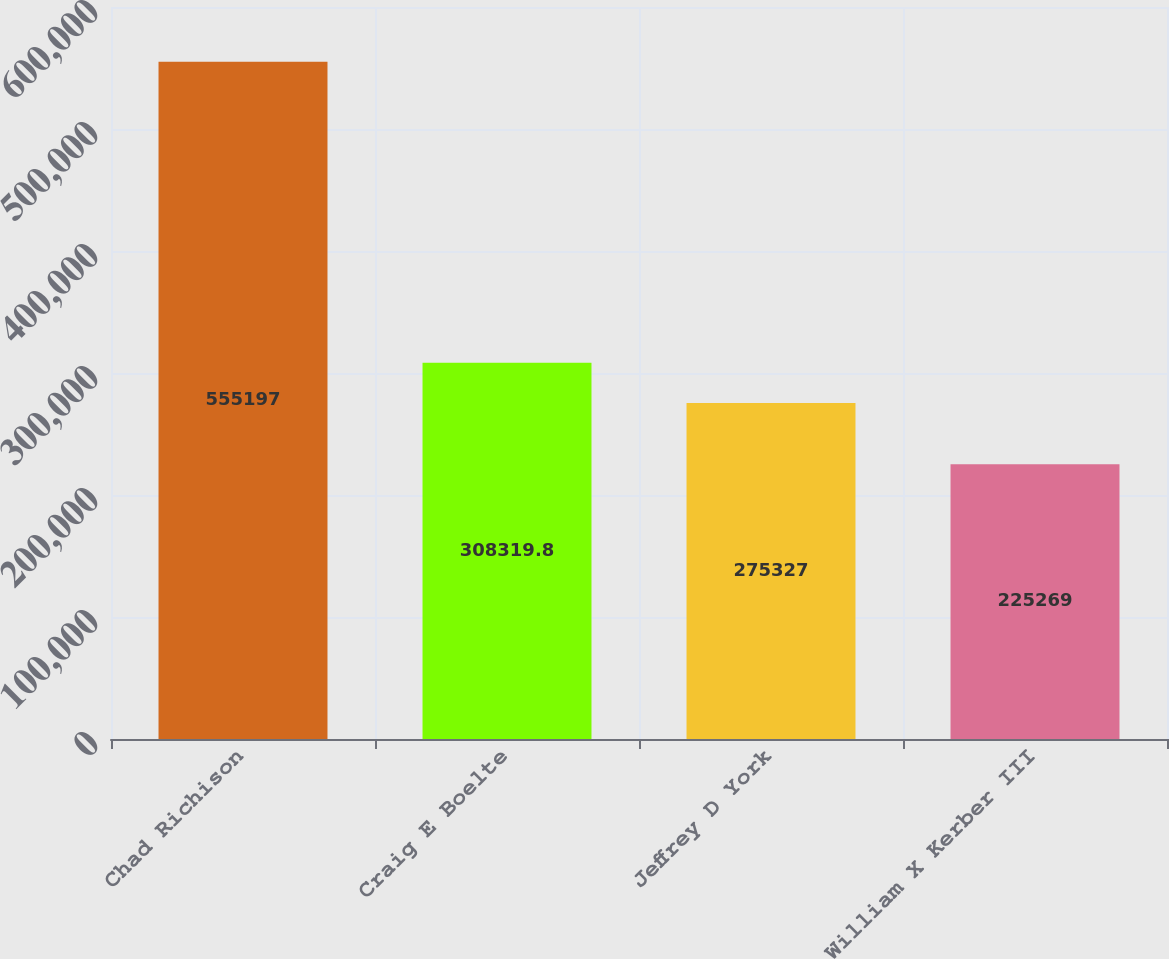<chart> <loc_0><loc_0><loc_500><loc_500><bar_chart><fcel>Chad Richison<fcel>Craig E Boelte<fcel>Jeffrey D York<fcel>William X Kerber III<nl><fcel>555197<fcel>308320<fcel>275327<fcel>225269<nl></chart> 